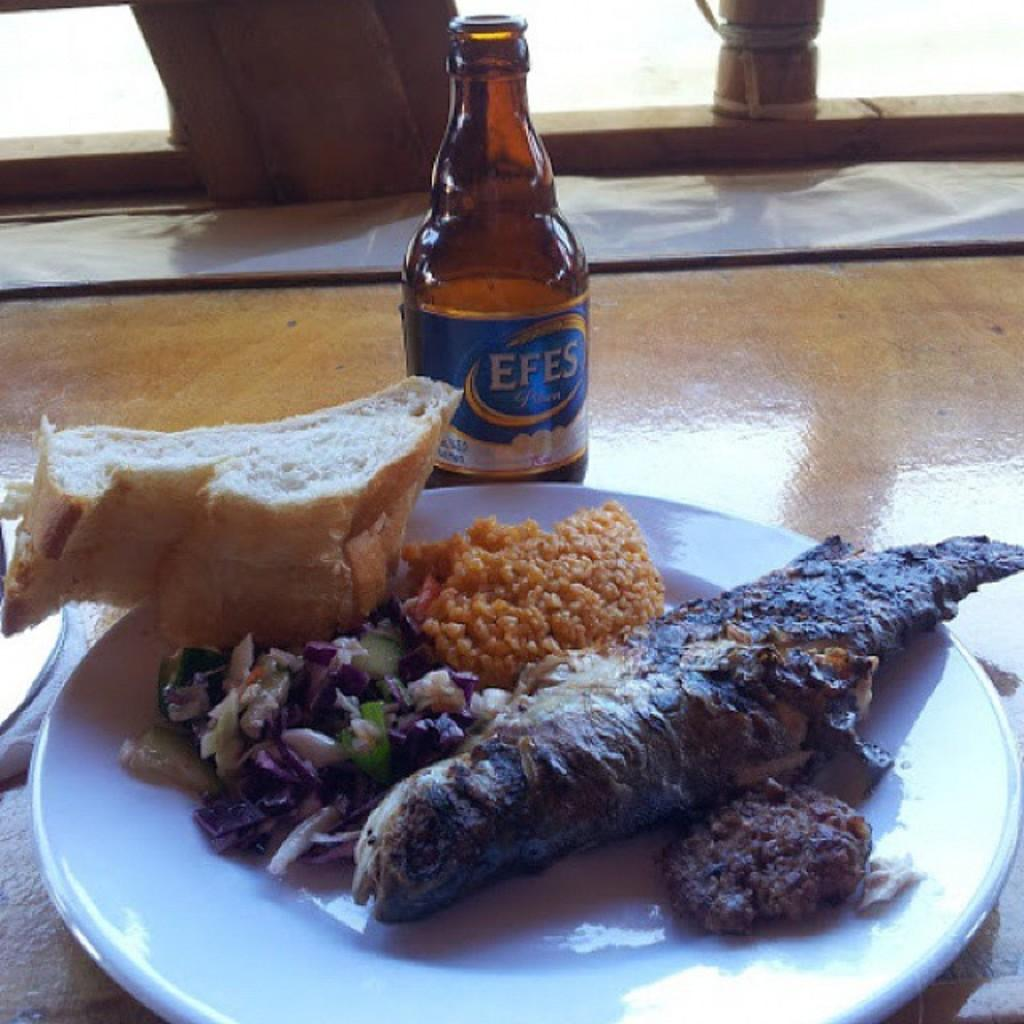What is on the plate that is visible in the image? There is a plate of food in the image. What else can be seen on the table in the image? There is a bottle on the table in the image. What material is the table made of? The table is made of wood. Is there a crown on the plate of food in the image? No, there is no crown present on the plate of food in the image. 